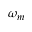<formula> <loc_0><loc_0><loc_500><loc_500>\omega _ { m }</formula> 